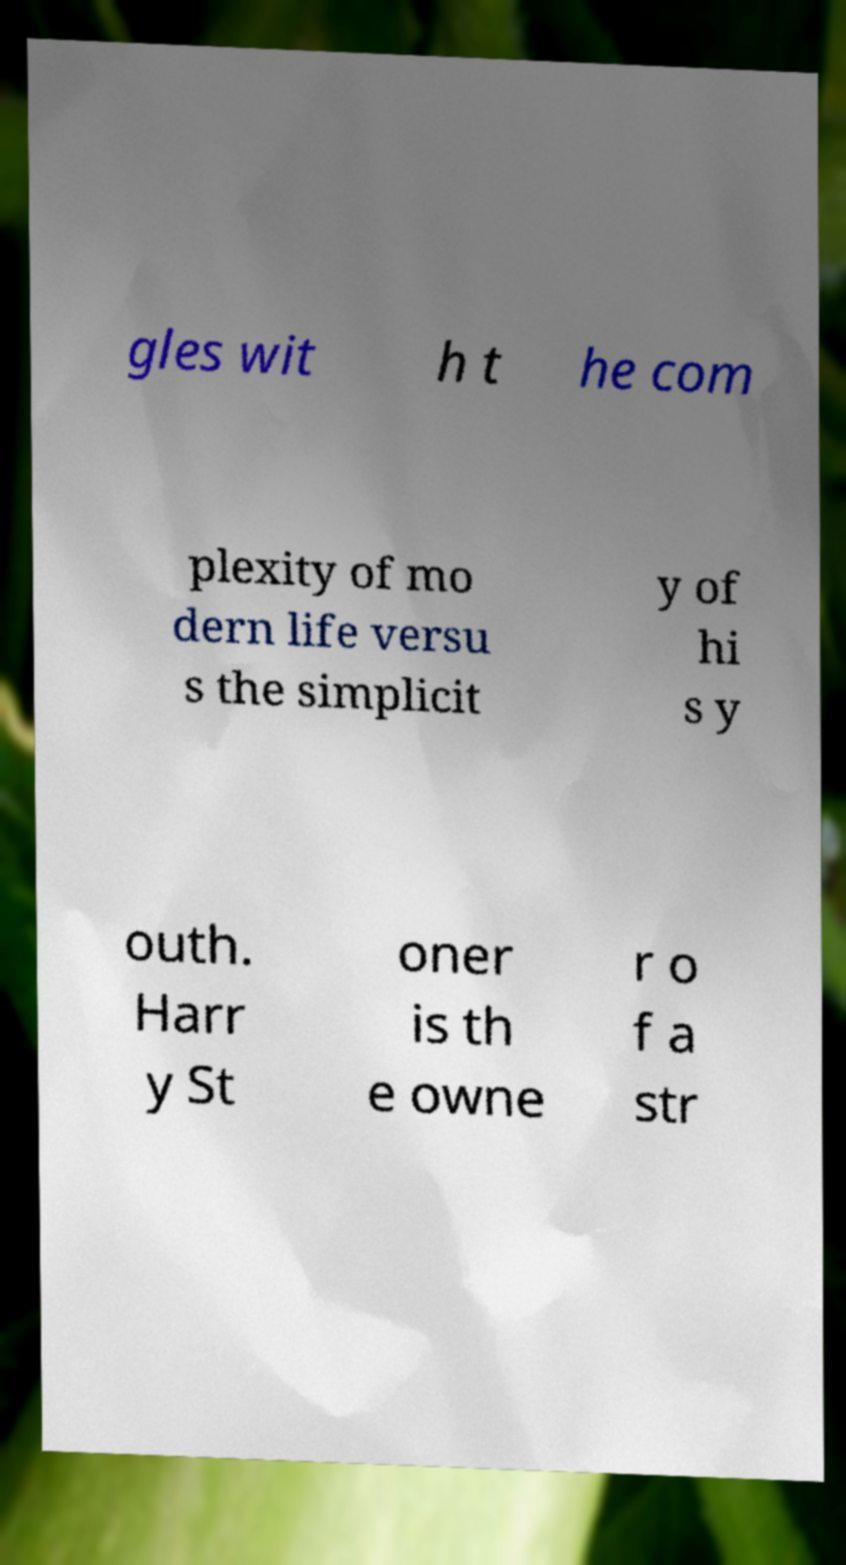I need the written content from this picture converted into text. Can you do that? gles wit h t he com plexity of mo dern life versu s the simplicit y of hi s y outh. Harr y St oner is th e owne r o f a str 